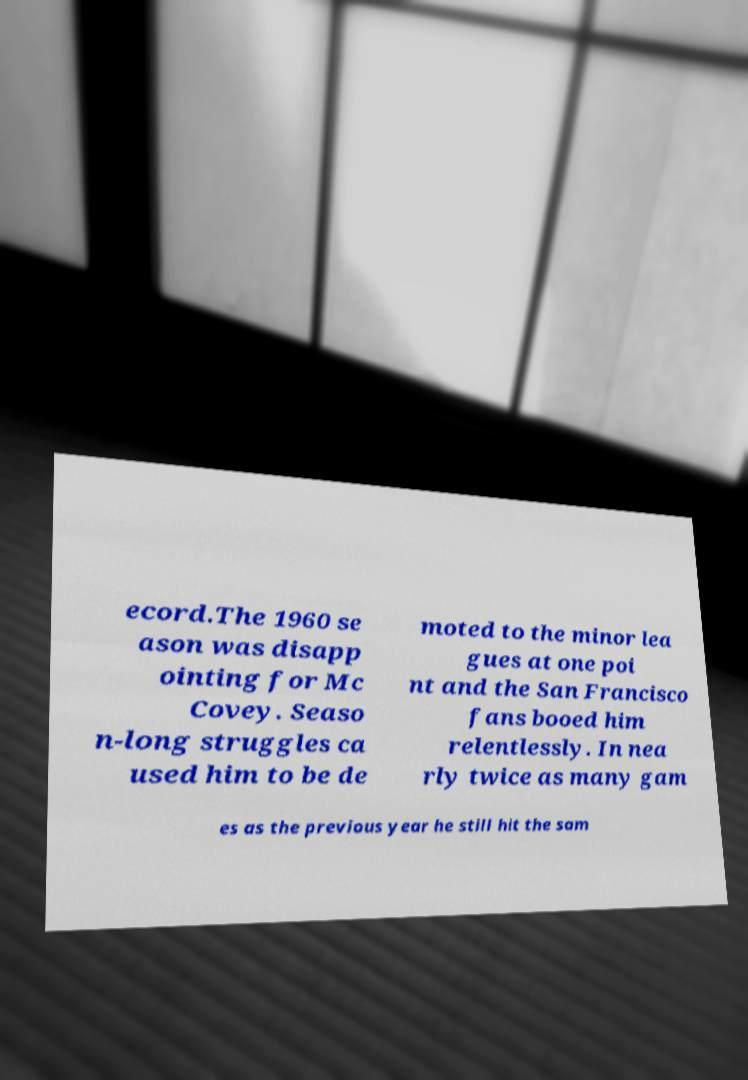Please identify and transcribe the text found in this image. ecord.The 1960 se ason was disapp ointing for Mc Covey. Seaso n-long struggles ca used him to be de moted to the minor lea gues at one poi nt and the San Francisco fans booed him relentlessly. In nea rly twice as many gam es as the previous year he still hit the sam 